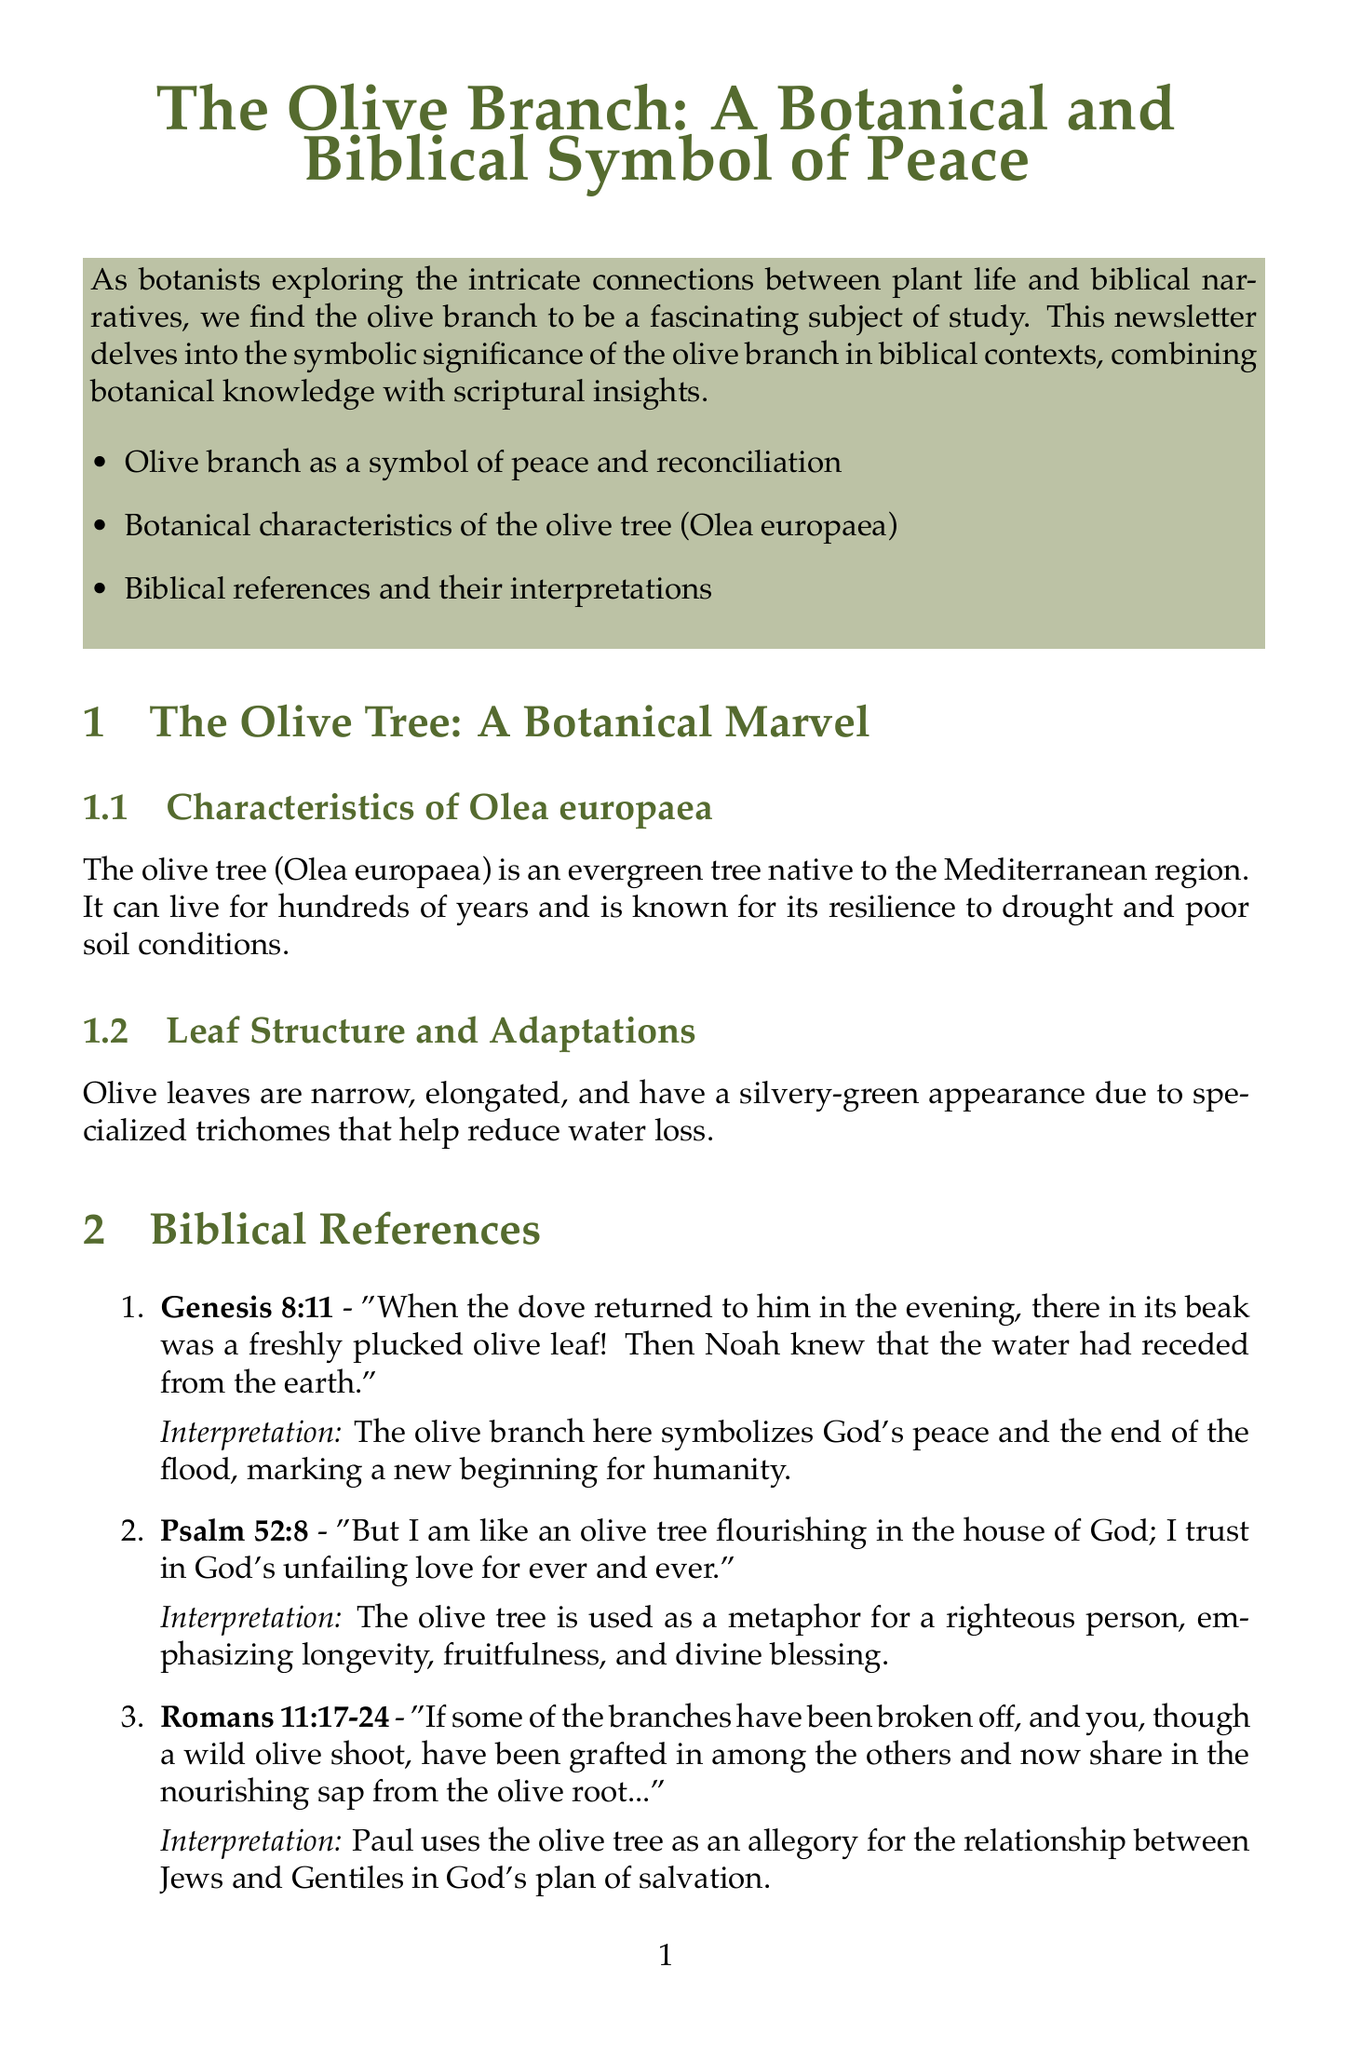What is the title of the newsletter? The title of the newsletter is clearly stated at the beginning, highlighting the subject of study.
Answer: The Olive Branch: A Botanical and Biblical Symbol of Peace What is the scientific name of the olive tree? The scientific name is mentioned in the botanical section, specifically under the characteristics description of the olive tree.
Answer: Olea europaea Which biblical passage mentions the dove and the olive leaf? The specific biblical passage is included in the section detailing biblical references and their interpretations.
Answer: Genesis 8:11 What does the olive branch symbolize in Genesis 8:11? The interpretation provided after the passage explains the symbolic meaning attributed to the olive branch in this context.
Answer: God's peace and the end of the flood How many key points are listed in the introduction? The introduction outlines the key points regarding the olive branch, and the exact number is directly noted in that section.
Answer: Three What is the interpretation of Psalm 52:8? The interpretation of this verse is included directly after the passage, explaining the metaphor used.
Answer: A metaphor for a righteous person What does the illustration titled "Olive Branch with Leaves and Fruit" depict? The description provided alongside the title gives a clear indication of what the illustration represents.
Answer: The structure of an olive branch, including leaves, fruit, and stem What is the call to action at the end of the newsletter? The conclusion section includes a call to action inviting readers to the next topic to be covered in the next issue.
Answer: Explore the fig tree and its prominence in biblical parables! 